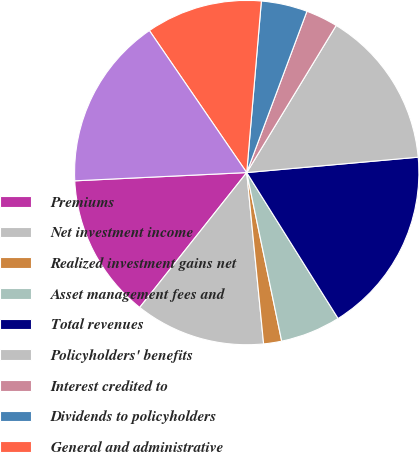<chart> <loc_0><loc_0><loc_500><loc_500><pie_chart><fcel>Premiums<fcel>Net investment income<fcel>Realized investment gains net<fcel>Asset management fees and<fcel>Total revenues<fcel>Policyholders' benefits<fcel>Interest credited to<fcel>Dividends to policyholders<fcel>General and administrative<fcel>Total benefits and expenses<nl><fcel>13.56%<fcel>12.24%<fcel>1.69%<fcel>5.65%<fcel>17.52%<fcel>14.88%<fcel>3.01%<fcel>4.33%<fcel>10.92%<fcel>16.2%<nl></chart> 